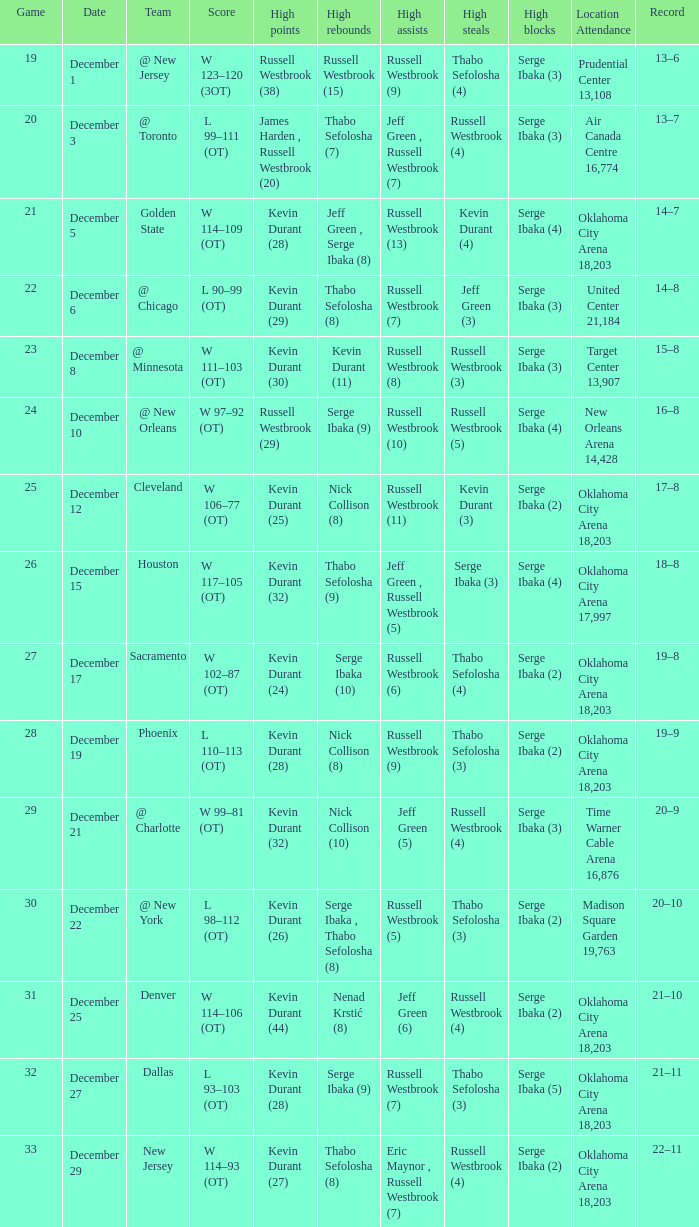Who had the high rebounds record on December 12? Nick Collison (8). 